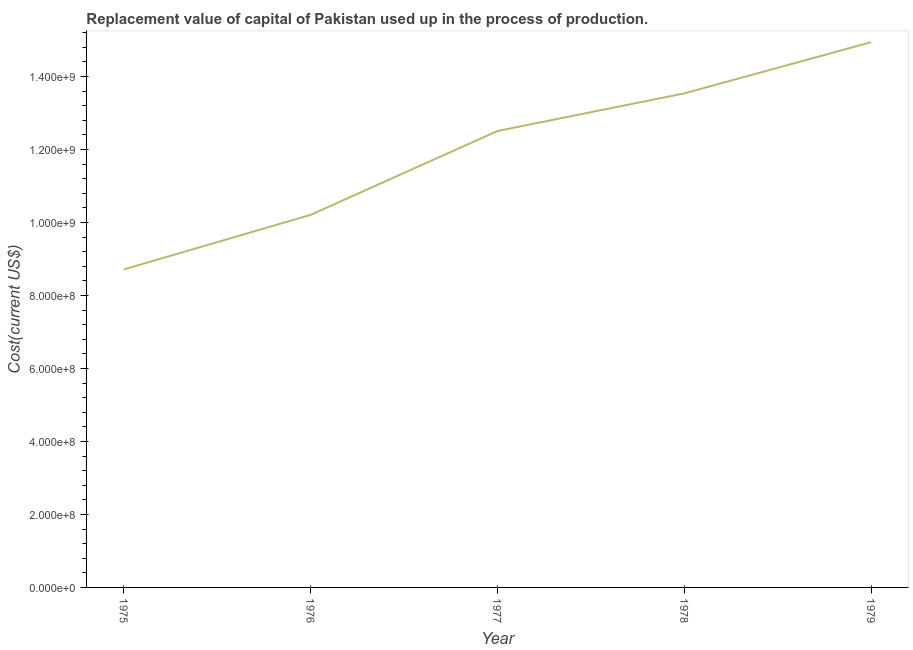What is the consumption of fixed capital in 1976?
Give a very brief answer. 1.02e+09. Across all years, what is the maximum consumption of fixed capital?
Provide a succinct answer. 1.49e+09. Across all years, what is the minimum consumption of fixed capital?
Offer a terse response. 8.71e+08. In which year was the consumption of fixed capital maximum?
Your answer should be compact. 1979. In which year was the consumption of fixed capital minimum?
Ensure brevity in your answer.  1975. What is the sum of the consumption of fixed capital?
Ensure brevity in your answer.  5.99e+09. What is the difference between the consumption of fixed capital in 1976 and 1979?
Give a very brief answer. -4.73e+08. What is the average consumption of fixed capital per year?
Keep it short and to the point. 1.20e+09. What is the median consumption of fixed capital?
Keep it short and to the point. 1.25e+09. What is the ratio of the consumption of fixed capital in 1975 to that in 1978?
Provide a succinct answer. 0.64. Is the consumption of fixed capital in 1976 less than that in 1978?
Provide a short and direct response. Yes. What is the difference between the highest and the second highest consumption of fixed capital?
Provide a short and direct response. 1.40e+08. What is the difference between the highest and the lowest consumption of fixed capital?
Make the answer very short. 6.23e+08. How many lines are there?
Ensure brevity in your answer.  1. Does the graph contain grids?
Provide a short and direct response. No. What is the title of the graph?
Provide a short and direct response. Replacement value of capital of Pakistan used up in the process of production. What is the label or title of the X-axis?
Ensure brevity in your answer.  Year. What is the label or title of the Y-axis?
Ensure brevity in your answer.  Cost(current US$). What is the Cost(current US$) in 1975?
Ensure brevity in your answer.  8.71e+08. What is the Cost(current US$) in 1976?
Your response must be concise. 1.02e+09. What is the Cost(current US$) of 1977?
Ensure brevity in your answer.  1.25e+09. What is the Cost(current US$) of 1978?
Your answer should be very brief. 1.35e+09. What is the Cost(current US$) in 1979?
Provide a succinct answer. 1.49e+09. What is the difference between the Cost(current US$) in 1975 and 1976?
Your response must be concise. -1.50e+08. What is the difference between the Cost(current US$) in 1975 and 1977?
Offer a terse response. -3.79e+08. What is the difference between the Cost(current US$) in 1975 and 1978?
Make the answer very short. -4.82e+08. What is the difference between the Cost(current US$) in 1975 and 1979?
Your answer should be compact. -6.23e+08. What is the difference between the Cost(current US$) in 1976 and 1977?
Your answer should be very brief. -2.30e+08. What is the difference between the Cost(current US$) in 1976 and 1978?
Your answer should be very brief. -3.33e+08. What is the difference between the Cost(current US$) in 1976 and 1979?
Provide a short and direct response. -4.73e+08. What is the difference between the Cost(current US$) in 1977 and 1978?
Your answer should be very brief. -1.03e+08. What is the difference between the Cost(current US$) in 1977 and 1979?
Make the answer very short. -2.43e+08. What is the difference between the Cost(current US$) in 1978 and 1979?
Ensure brevity in your answer.  -1.40e+08. What is the ratio of the Cost(current US$) in 1975 to that in 1976?
Provide a succinct answer. 0.85. What is the ratio of the Cost(current US$) in 1975 to that in 1977?
Make the answer very short. 0.7. What is the ratio of the Cost(current US$) in 1975 to that in 1978?
Offer a very short reply. 0.64. What is the ratio of the Cost(current US$) in 1975 to that in 1979?
Provide a short and direct response. 0.58. What is the ratio of the Cost(current US$) in 1976 to that in 1977?
Offer a terse response. 0.82. What is the ratio of the Cost(current US$) in 1976 to that in 1978?
Your response must be concise. 0.75. What is the ratio of the Cost(current US$) in 1976 to that in 1979?
Ensure brevity in your answer.  0.68. What is the ratio of the Cost(current US$) in 1977 to that in 1978?
Offer a very short reply. 0.92. What is the ratio of the Cost(current US$) in 1977 to that in 1979?
Ensure brevity in your answer.  0.84. What is the ratio of the Cost(current US$) in 1978 to that in 1979?
Offer a very short reply. 0.91. 